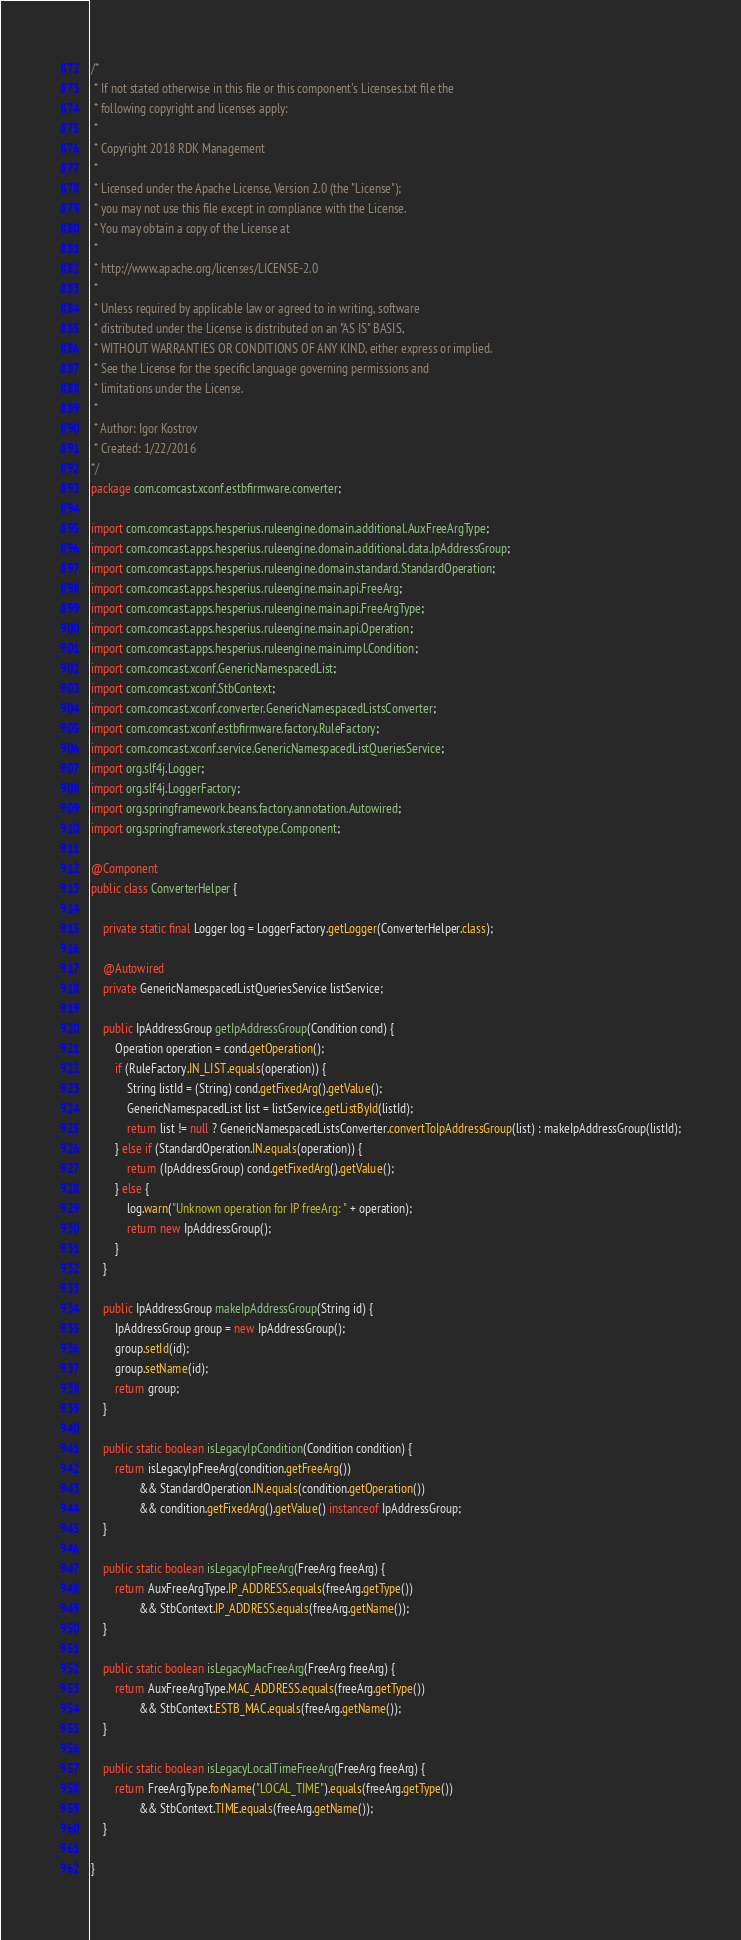<code> <loc_0><loc_0><loc_500><loc_500><_Java_>/* 
 * If not stated otherwise in this file or this component's Licenses.txt file the 
 * following copyright and licenses apply:
 *
 * Copyright 2018 RDK Management
 *
 * Licensed under the Apache License, Version 2.0 (the "License");
 * you may not use this file except in compliance with the License.
 * You may obtain a copy of the License at
 *
 * http://www.apache.org/licenses/LICENSE-2.0
 *
 * Unless required by applicable law or agreed to in writing, software
 * distributed under the License is distributed on an "AS IS" BASIS,
 * WITHOUT WARRANTIES OR CONDITIONS OF ANY KIND, either express or implied.
 * See the License for the specific language governing permissions and
 * limitations under the License.
 *
 * Author: Igor Kostrov
 * Created: 1/22/2016
*/
package com.comcast.xconf.estbfirmware.converter;

import com.comcast.apps.hesperius.ruleengine.domain.additional.AuxFreeArgType;
import com.comcast.apps.hesperius.ruleengine.domain.additional.data.IpAddressGroup;
import com.comcast.apps.hesperius.ruleengine.domain.standard.StandardOperation;
import com.comcast.apps.hesperius.ruleengine.main.api.FreeArg;
import com.comcast.apps.hesperius.ruleengine.main.api.FreeArgType;
import com.comcast.apps.hesperius.ruleengine.main.api.Operation;
import com.comcast.apps.hesperius.ruleengine.main.impl.Condition;
import com.comcast.xconf.GenericNamespacedList;
import com.comcast.xconf.StbContext;
import com.comcast.xconf.converter.GenericNamespacedListsConverter;
import com.comcast.xconf.estbfirmware.factory.RuleFactory;
import com.comcast.xconf.service.GenericNamespacedListQueriesService;
import org.slf4j.Logger;
import org.slf4j.LoggerFactory;
import org.springframework.beans.factory.annotation.Autowired;
import org.springframework.stereotype.Component;

@Component
public class ConverterHelper {

    private static final Logger log = LoggerFactory.getLogger(ConverterHelper.class);

    @Autowired
    private GenericNamespacedListQueriesService listService;

    public IpAddressGroup getIpAddressGroup(Condition cond) {
        Operation operation = cond.getOperation();
        if (RuleFactory.IN_LIST.equals(operation)) {
            String listId = (String) cond.getFixedArg().getValue();
            GenericNamespacedList list = listService.getListById(listId);
            return list != null ? GenericNamespacedListsConverter.convertToIpAddressGroup(list) : makeIpAddressGroup(listId);
        } else if (StandardOperation.IN.equals(operation)) {
            return (IpAddressGroup) cond.getFixedArg().getValue();
        } else {
            log.warn("Unknown operation for IP freeArg: " + operation);
            return new IpAddressGroup();
        }
    }

    public IpAddressGroup makeIpAddressGroup(String id) {
        IpAddressGroup group = new IpAddressGroup();
        group.setId(id);
        group.setName(id);
        return group;
    }

    public static boolean isLegacyIpCondition(Condition condition) {
        return isLegacyIpFreeArg(condition.getFreeArg())
                && StandardOperation.IN.equals(condition.getOperation())
                && condition.getFixedArg().getValue() instanceof IpAddressGroup;
    }

    public static boolean isLegacyIpFreeArg(FreeArg freeArg) {
        return AuxFreeArgType.IP_ADDRESS.equals(freeArg.getType())
                && StbContext.IP_ADDRESS.equals(freeArg.getName());
    }

    public static boolean isLegacyMacFreeArg(FreeArg freeArg) {
        return AuxFreeArgType.MAC_ADDRESS.equals(freeArg.getType())
                && StbContext.ESTB_MAC.equals(freeArg.getName());
    }

    public static boolean isLegacyLocalTimeFreeArg(FreeArg freeArg) {
        return FreeArgType.forName("LOCAL_TIME").equals(freeArg.getType())
                && StbContext.TIME.equals(freeArg.getName());
    }

}
</code> 